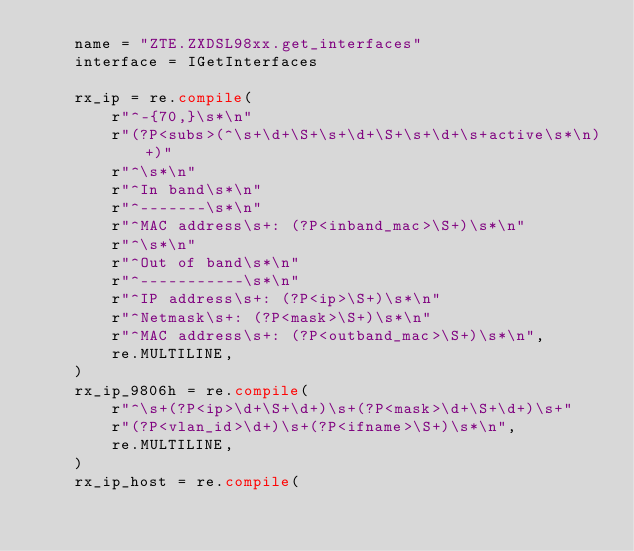Convert code to text. <code><loc_0><loc_0><loc_500><loc_500><_Python_>    name = "ZTE.ZXDSL98xx.get_interfaces"
    interface = IGetInterfaces

    rx_ip = re.compile(
        r"^-{70,}\s*\n"
        r"(?P<subs>(^\s+\d+\S+\s+\d+\S+\s+\d+\s+active\s*\n)+)"
        r"^\s*\n"
        r"^In band\s*\n"
        r"^-------\s*\n"
        r"^MAC address\s+: (?P<inband_mac>\S+)\s*\n"
        r"^\s*\n"
        r"^Out of band\s*\n"
        r"^-----------\s*\n"
        r"^IP address\s+: (?P<ip>\S+)\s*\n"
        r"^Netmask\s+: (?P<mask>\S+)\s*\n"
        r"^MAC address\s+: (?P<outband_mac>\S+)\s*\n",
        re.MULTILINE,
    )
    rx_ip_9806h = re.compile(
        r"^\s+(?P<ip>\d+\S+\d+)\s+(?P<mask>\d+\S+\d+)\s+"
        r"(?P<vlan_id>\d+)\s+(?P<ifname>\S+)\s*\n",
        re.MULTILINE,
    )
    rx_ip_host = re.compile(</code> 